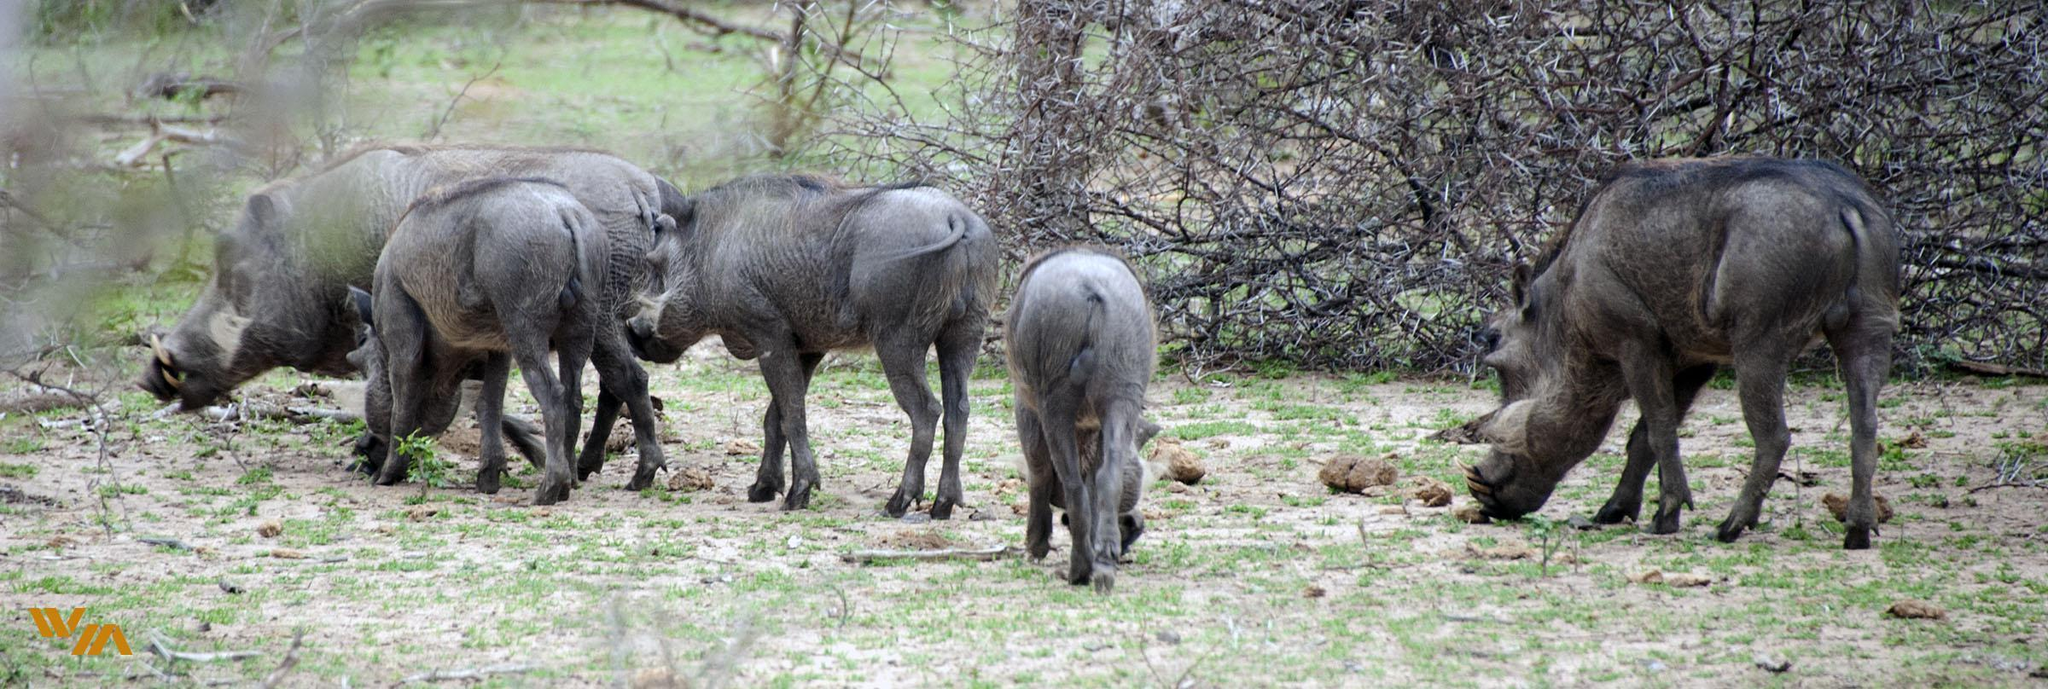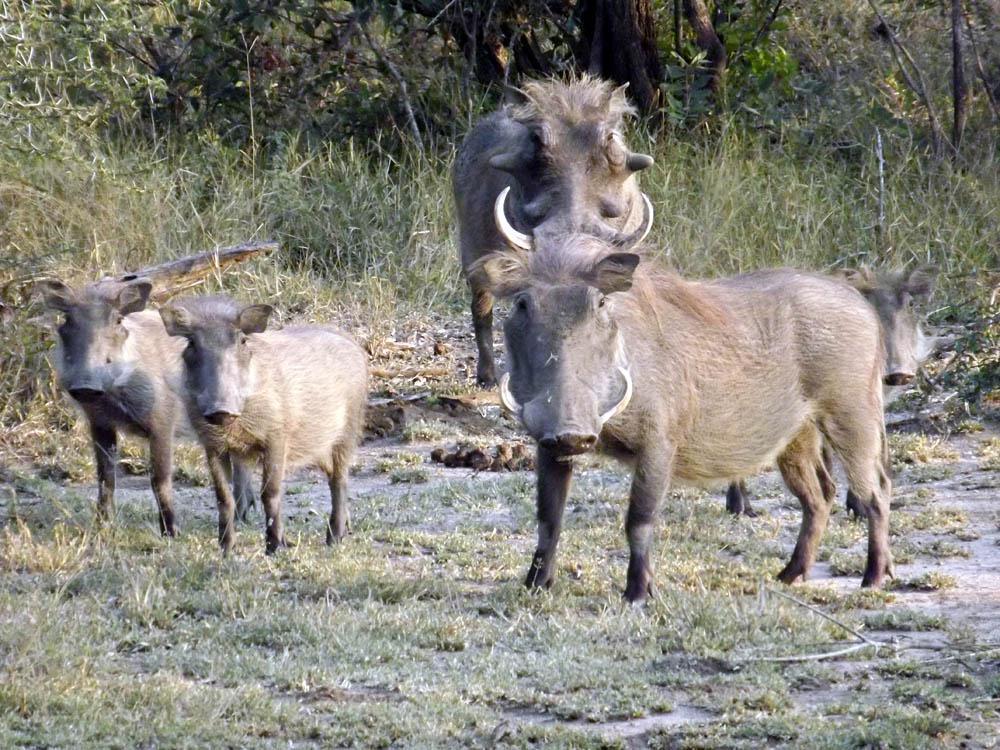The first image is the image on the left, the second image is the image on the right. For the images shown, is this caption "There are exactly 5 animals in the image on the right." true? Answer yes or no. No. 